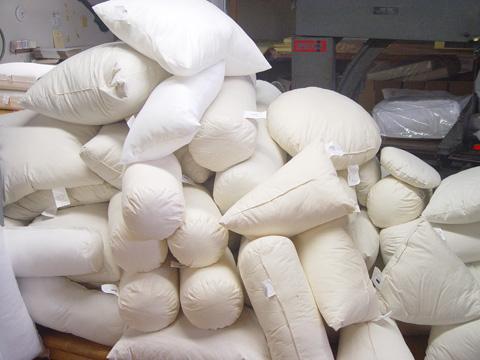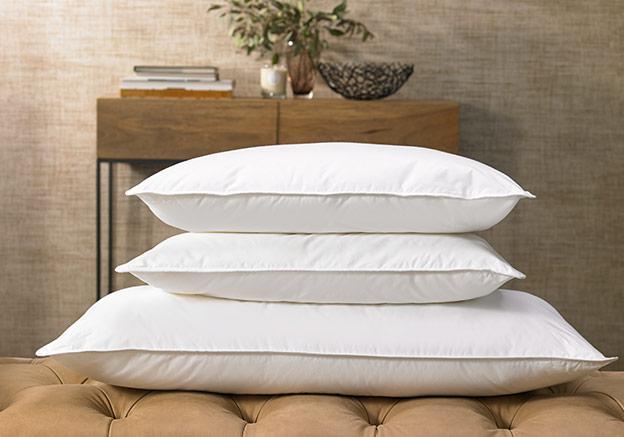The first image is the image on the left, the second image is the image on the right. Examine the images to the left and right. Is the description "The right image shows at least four pillows on a bed with a brown headboard and white bedding." accurate? Answer yes or no. No. The first image is the image on the left, the second image is the image on the right. For the images displayed, is the sentence "There are fewer than seven pillows visible in total." factually correct? Answer yes or no. No. 